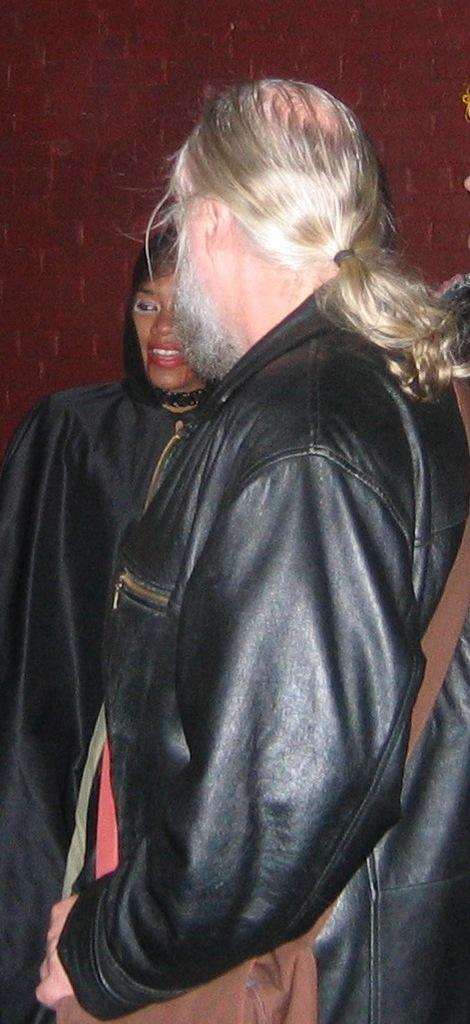What is the main subject of the image? There is a person in the image. What is the person wearing? The person is wearing a bag. Can you describe the woman in the background of the image? The woman in the background is wearing a black dress. What can be seen in the background of the image besides the woman? There is a brick wall in the background of the image. How many trucks are parked next to the person in the image? There are no trucks visible in the image. What type of copy is the person holding in the image? The person is not holding any copy in the image. 